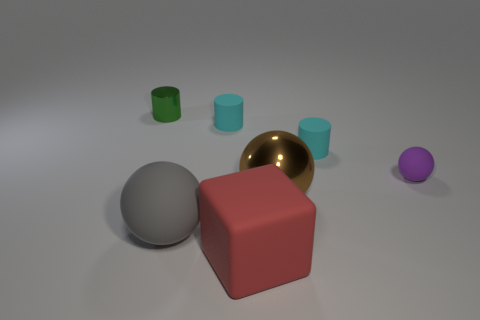Add 1 gray cylinders. How many objects exist? 8 Subtract all blocks. How many objects are left? 6 Add 6 large purple cubes. How many large purple cubes exist? 6 Subtract 0 cyan spheres. How many objects are left? 7 Subtract all big gray rubber spheres. Subtract all small purple rubber spheres. How many objects are left? 5 Add 7 large gray rubber things. How many large gray rubber things are left? 8 